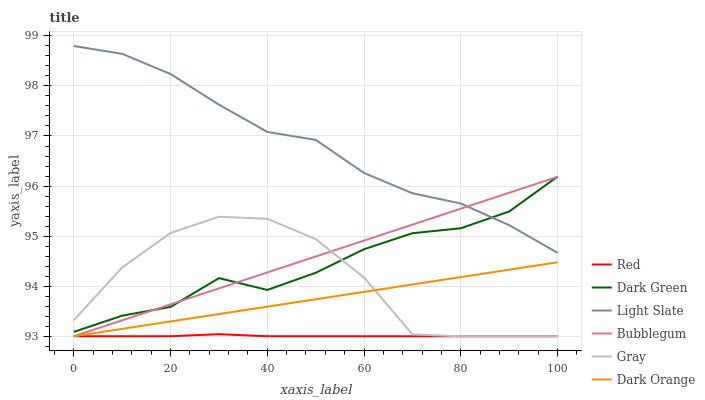Does Dark Orange have the minimum area under the curve?
Answer yes or no. No. Does Dark Orange have the maximum area under the curve?
Answer yes or no. No. Is Dark Orange the smoothest?
Answer yes or no. No. Is Dark Orange the roughest?
Answer yes or no. No. Does Light Slate have the lowest value?
Answer yes or no. No. Does Dark Orange have the highest value?
Answer yes or no. No. Is Dark Orange less than Dark Green?
Answer yes or no. Yes. Is Dark Green greater than Red?
Answer yes or no. Yes. Does Dark Orange intersect Dark Green?
Answer yes or no. No. 